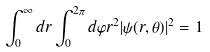Convert formula to latex. <formula><loc_0><loc_0><loc_500><loc_500>\int _ { 0 } ^ { \infty } d r \int _ { 0 } ^ { 2 \pi } d \varphi r ^ { 2 } | \psi ( r , \theta ) | ^ { 2 } = 1</formula> 